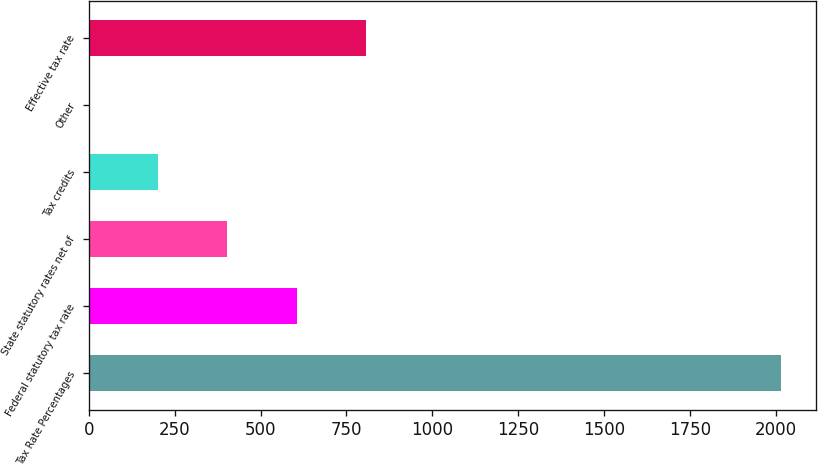Convert chart. <chart><loc_0><loc_0><loc_500><loc_500><bar_chart><fcel>Tax Rate Percentages<fcel>Federal statutory tax rate<fcel>State statutory rates net of<fcel>Tax credits<fcel>Other<fcel>Effective tax rate<nl><fcel>2016<fcel>604.94<fcel>403.36<fcel>201.78<fcel>0.2<fcel>806.52<nl></chart> 